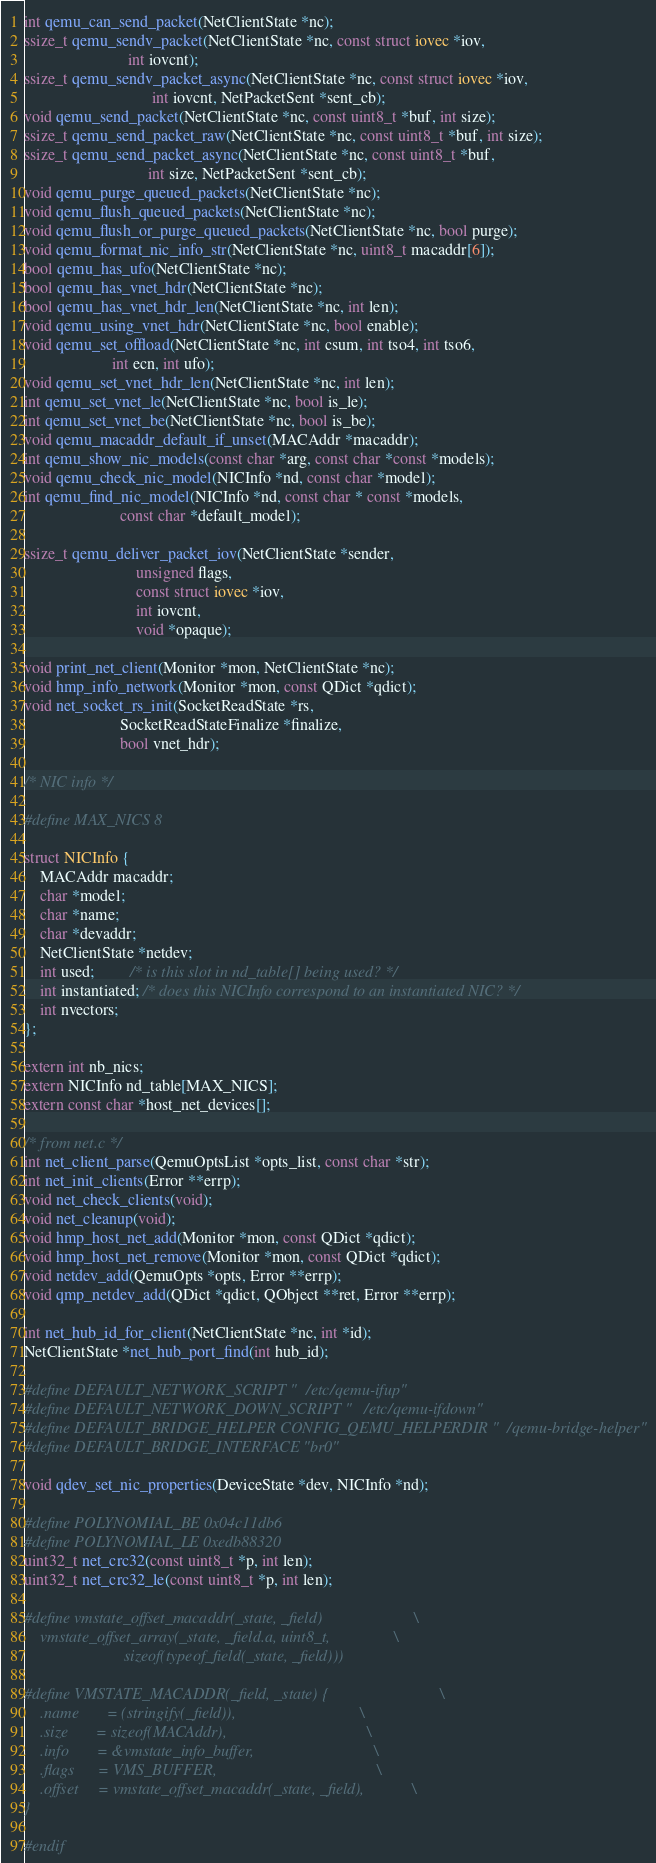<code> <loc_0><loc_0><loc_500><loc_500><_C_>int qemu_can_send_packet(NetClientState *nc);
ssize_t qemu_sendv_packet(NetClientState *nc, const struct iovec *iov,
                          int iovcnt);
ssize_t qemu_sendv_packet_async(NetClientState *nc, const struct iovec *iov,
                                int iovcnt, NetPacketSent *sent_cb);
void qemu_send_packet(NetClientState *nc, const uint8_t *buf, int size);
ssize_t qemu_send_packet_raw(NetClientState *nc, const uint8_t *buf, int size);
ssize_t qemu_send_packet_async(NetClientState *nc, const uint8_t *buf,
                               int size, NetPacketSent *sent_cb);
void qemu_purge_queued_packets(NetClientState *nc);
void qemu_flush_queued_packets(NetClientState *nc);
void qemu_flush_or_purge_queued_packets(NetClientState *nc, bool purge);
void qemu_format_nic_info_str(NetClientState *nc, uint8_t macaddr[6]);
bool qemu_has_ufo(NetClientState *nc);
bool qemu_has_vnet_hdr(NetClientState *nc);
bool qemu_has_vnet_hdr_len(NetClientState *nc, int len);
void qemu_using_vnet_hdr(NetClientState *nc, bool enable);
void qemu_set_offload(NetClientState *nc, int csum, int tso4, int tso6,
                      int ecn, int ufo);
void qemu_set_vnet_hdr_len(NetClientState *nc, int len);
int qemu_set_vnet_le(NetClientState *nc, bool is_le);
int qemu_set_vnet_be(NetClientState *nc, bool is_be);
void qemu_macaddr_default_if_unset(MACAddr *macaddr);
int qemu_show_nic_models(const char *arg, const char *const *models);
void qemu_check_nic_model(NICInfo *nd, const char *model);
int qemu_find_nic_model(NICInfo *nd, const char * const *models,
                        const char *default_model);

ssize_t qemu_deliver_packet_iov(NetClientState *sender,
                            unsigned flags,
                            const struct iovec *iov,
                            int iovcnt,
                            void *opaque);

void print_net_client(Monitor *mon, NetClientState *nc);
void hmp_info_network(Monitor *mon, const QDict *qdict);
void net_socket_rs_init(SocketReadState *rs,
                        SocketReadStateFinalize *finalize,
                        bool vnet_hdr);

/* NIC info */

#define MAX_NICS 8

struct NICInfo {
    MACAddr macaddr;
    char *model;
    char *name;
    char *devaddr;
    NetClientState *netdev;
    int used;         /* is this slot in nd_table[] being used? */
    int instantiated; /* does this NICInfo correspond to an instantiated NIC? */
    int nvectors;
};

extern int nb_nics;
extern NICInfo nd_table[MAX_NICS];
extern const char *host_net_devices[];

/* from net.c */
int net_client_parse(QemuOptsList *opts_list, const char *str);
int net_init_clients(Error **errp);
void net_check_clients(void);
void net_cleanup(void);
void hmp_host_net_add(Monitor *mon, const QDict *qdict);
void hmp_host_net_remove(Monitor *mon, const QDict *qdict);
void netdev_add(QemuOpts *opts, Error **errp);
void qmp_netdev_add(QDict *qdict, QObject **ret, Error **errp);

int net_hub_id_for_client(NetClientState *nc, int *id);
NetClientState *net_hub_port_find(int hub_id);

#define DEFAULT_NETWORK_SCRIPT "/etc/qemu-ifup"
#define DEFAULT_NETWORK_DOWN_SCRIPT "/etc/qemu-ifdown"
#define DEFAULT_BRIDGE_HELPER CONFIG_QEMU_HELPERDIR "/qemu-bridge-helper"
#define DEFAULT_BRIDGE_INTERFACE "br0"

void qdev_set_nic_properties(DeviceState *dev, NICInfo *nd);

#define POLYNOMIAL_BE 0x04c11db6
#define POLYNOMIAL_LE 0xedb88320
uint32_t net_crc32(const uint8_t *p, int len);
uint32_t net_crc32_le(const uint8_t *p, int len);

#define vmstate_offset_macaddr(_state, _field)                       \
    vmstate_offset_array(_state, _field.a, uint8_t,                \
                         sizeof(typeof_field(_state, _field)))

#define VMSTATE_MACADDR(_field, _state) {                            \
    .name       = (stringify(_field)),                               \
    .size       = sizeof(MACAddr),                                   \
    .info       = &vmstate_info_buffer,                              \
    .flags      = VMS_BUFFER,                                        \
    .offset     = vmstate_offset_macaddr(_state, _field),            \
}

#endif
</code> 